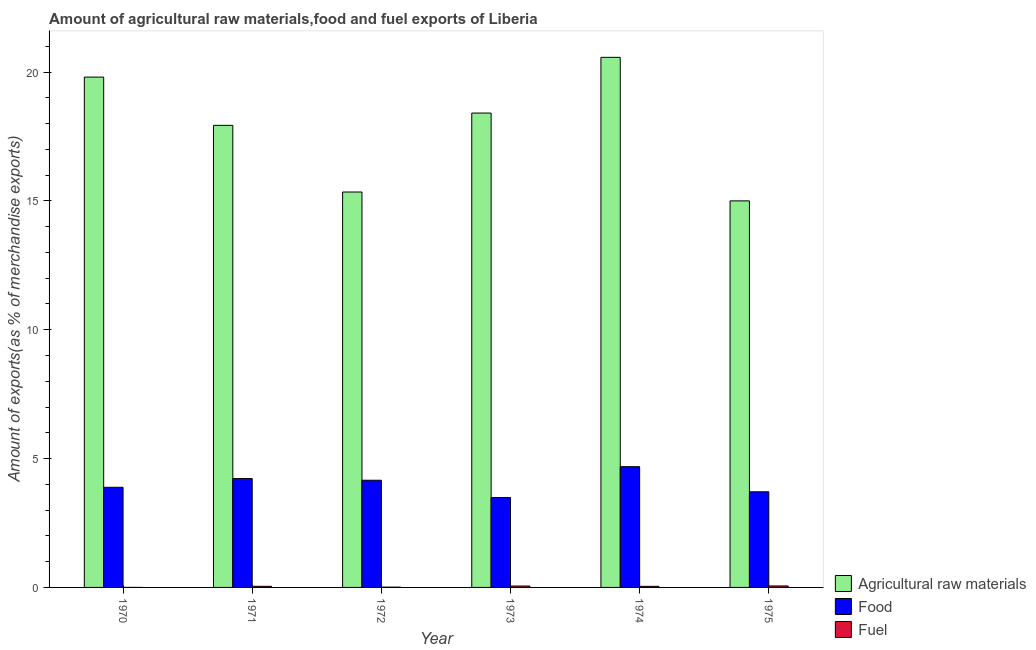How many different coloured bars are there?
Keep it short and to the point. 3. Are the number of bars per tick equal to the number of legend labels?
Keep it short and to the point. Yes. Are the number of bars on each tick of the X-axis equal?
Give a very brief answer. Yes. How many bars are there on the 6th tick from the left?
Your response must be concise. 3. What is the percentage of food exports in 1970?
Your answer should be compact. 3.88. Across all years, what is the maximum percentage of raw materials exports?
Your response must be concise. 20.57. Across all years, what is the minimum percentage of food exports?
Your response must be concise. 3.49. In which year was the percentage of raw materials exports maximum?
Offer a very short reply. 1974. In which year was the percentage of food exports minimum?
Make the answer very short. 1973. What is the total percentage of fuel exports in the graph?
Offer a very short reply. 0.21. What is the difference between the percentage of fuel exports in 1970 and that in 1974?
Offer a terse response. -0.04. What is the difference between the percentage of food exports in 1975 and the percentage of raw materials exports in 1970?
Give a very brief answer. -0.17. What is the average percentage of raw materials exports per year?
Give a very brief answer. 17.84. In the year 1970, what is the difference between the percentage of food exports and percentage of raw materials exports?
Provide a short and direct response. 0. What is the ratio of the percentage of fuel exports in 1973 to that in 1975?
Offer a very short reply. 0.95. Is the percentage of raw materials exports in 1970 less than that in 1973?
Your response must be concise. No. Is the difference between the percentage of raw materials exports in 1971 and 1974 greater than the difference between the percentage of fuel exports in 1971 and 1974?
Give a very brief answer. No. What is the difference between the highest and the second highest percentage of fuel exports?
Provide a short and direct response. 0. What is the difference between the highest and the lowest percentage of fuel exports?
Your answer should be compact. 0.06. In how many years, is the percentage of raw materials exports greater than the average percentage of raw materials exports taken over all years?
Your response must be concise. 4. What does the 1st bar from the left in 1974 represents?
Ensure brevity in your answer.  Agricultural raw materials. What does the 3rd bar from the right in 1974 represents?
Ensure brevity in your answer.  Agricultural raw materials. Is it the case that in every year, the sum of the percentage of raw materials exports and percentage of food exports is greater than the percentage of fuel exports?
Provide a succinct answer. Yes. Are the values on the major ticks of Y-axis written in scientific E-notation?
Keep it short and to the point. No. Does the graph contain any zero values?
Make the answer very short. No. Does the graph contain grids?
Make the answer very short. No. How are the legend labels stacked?
Offer a very short reply. Vertical. What is the title of the graph?
Give a very brief answer. Amount of agricultural raw materials,food and fuel exports of Liberia. Does "Natural gas sources" appear as one of the legend labels in the graph?
Give a very brief answer. No. What is the label or title of the Y-axis?
Your answer should be compact. Amount of exports(as % of merchandise exports). What is the Amount of exports(as % of merchandise exports) of Agricultural raw materials in 1970?
Provide a succinct answer. 19.8. What is the Amount of exports(as % of merchandise exports) in Food in 1970?
Provide a succinct answer. 3.88. What is the Amount of exports(as % of merchandise exports) of Fuel in 1970?
Give a very brief answer. 0. What is the Amount of exports(as % of merchandise exports) in Agricultural raw materials in 1971?
Make the answer very short. 17.93. What is the Amount of exports(as % of merchandise exports) in Food in 1971?
Your response must be concise. 4.22. What is the Amount of exports(as % of merchandise exports) of Fuel in 1971?
Your answer should be compact. 0.04. What is the Amount of exports(as % of merchandise exports) in Agricultural raw materials in 1972?
Your response must be concise. 15.34. What is the Amount of exports(as % of merchandise exports) in Food in 1972?
Your answer should be very brief. 4.16. What is the Amount of exports(as % of merchandise exports) in Fuel in 1972?
Provide a short and direct response. 0.01. What is the Amount of exports(as % of merchandise exports) of Agricultural raw materials in 1973?
Provide a short and direct response. 18.41. What is the Amount of exports(as % of merchandise exports) in Food in 1973?
Provide a short and direct response. 3.49. What is the Amount of exports(as % of merchandise exports) in Fuel in 1973?
Your answer should be compact. 0.05. What is the Amount of exports(as % of merchandise exports) in Agricultural raw materials in 1974?
Provide a succinct answer. 20.57. What is the Amount of exports(as % of merchandise exports) of Food in 1974?
Offer a very short reply. 4.69. What is the Amount of exports(as % of merchandise exports) of Fuel in 1974?
Ensure brevity in your answer.  0.04. What is the Amount of exports(as % of merchandise exports) in Agricultural raw materials in 1975?
Make the answer very short. 15. What is the Amount of exports(as % of merchandise exports) in Food in 1975?
Provide a succinct answer. 3.71. What is the Amount of exports(as % of merchandise exports) of Fuel in 1975?
Provide a succinct answer. 0.06. Across all years, what is the maximum Amount of exports(as % of merchandise exports) in Agricultural raw materials?
Ensure brevity in your answer.  20.57. Across all years, what is the maximum Amount of exports(as % of merchandise exports) of Food?
Keep it short and to the point. 4.69. Across all years, what is the maximum Amount of exports(as % of merchandise exports) in Fuel?
Make the answer very short. 0.06. Across all years, what is the minimum Amount of exports(as % of merchandise exports) in Agricultural raw materials?
Provide a succinct answer. 15. Across all years, what is the minimum Amount of exports(as % of merchandise exports) in Food?
Your answer should be very brief. 3.49. Across all years, what is the minimum Amount of exports(as % of merchandise exports) in Fuel?
Provide a succinct answer. 0. What is the total Amount of exports(as % of merchandise exports) in Agricultural raw materials in the graph?
Make the answer very short. 107.05. What is the total Amount of exports(as % of merchandise exports) in Food in the graph?
Your answer should be compact. 24.15. What is the total Amount of exports(as % of merchandise exports) in Fuel in the graph?
Offer a terse response. 0.21. What is the difference between the Amount of exports(as % of merchandise exports) in Agricultural raw materials in 1970 and that in 1971?
Your answer should be compact. 1.87. What is the difference between the Amount of exports(as % of merchandise exports) of Food in 1970 and that in 1971?
Your answer should be compact. -0.34. What is the difference between the Amount of exports(as % of merchandise exports) of Fuel in 1970 and that in 1971?
Give a very brief answer. -0.04. What is the difference between the Amount of exports(as % of merchandise exports) in Agricultural raw materials in 1970 and that in 1972?
Your response must be concise. 4.46. What is the difference between the Amount of exports(as % of merchandise exports) of Food in 1970 and that in 1972?
Ensure brevity in your answer.  -0.27. What is the difference between the Amount of exports(as % of merchandise exports) of Fuel in 1970 and that in 1972?
Offer a terse response. -0.01. What is the difference between the Amount of exports(as % of merchandise exports) of Agricultural raw materials in 1970 and that in 1973?
Provide a short and direct response. 1.4. What is the difference between the Amount of exports(as % of merchandise exports) in Food in 1970 and that in 1973?
Your answer should be very brief. 0.4. What is the difference between the Amount of exports(as % of merchandise exports) in Fuel in 1970 and that in 1973?
Give a very brief answer. -0.05. What is the difference between the Amount of exports(as % of merchandise exports) in Agricultural raw materials in 1970 and that in 1974?
Ensure brevity in your answer.  -0.77. What is the difference between the Amount of exports(as % of merchandise exports) of Food in 1970 and that in 1974?
Offer a very short reply. -0.8. What is the difference between the Amount of exports(as % of merchandise exports) in Fuel in 1970 and that in 1974?
Give a very brief answer. -0.04. What is the difference between the Amount of exports(as % of merchandise exports) of Agricultural raw materials in 1970 and that in 1975?
Your answer should be compact. 4.8. What is the difference between the Amount of exports(as % of merchandise exports) of Food in 1970 and that in 1975?
Your answer should be very brief. 0.17. What is the difference between the Amount of exports(as % of merchandise exports) in Fuel in 1970 and that in 1975?
Ensure brevity in your answer.  -0.06. What is the difference between the Amount of exports(as % of merchandise exports) of Agricultural raw materials in 1971 and that in 1972?
Give a very brief answer. 2.59. What is the difference between the Amount of exports(as % of merchandise exports) of Food in 1971 and that in 1972?
Provide a short and direct response. 0.07. What is the difference between the Amount of exports(as % of merchandise exports) in Fuel in 1971 and that in 1972?
Provide a short and direct response. 0.03. What is the difference between the Amount of exports(as % of merchandise exports) of Agricultural raw materials in 1971 and that in 1973?
Your answer should be very brief. -0.48. What is the difference between the Amount of exports(as % of merchandise exports) in Food in 1971 and that in 1973?
Ensure brevity in your answer.  0.74. What is the difference between the Amount of exports(as % of merchandise exports) of Fuel in 1971 and that in 1973?
Make the answer very short. -0.01. What is the difference between the Amount of exports(as % of merchandise exports) of Agricultural raw materials in 1971 and that in 1974?
Ensure brevity in your answer.  -2.64. What is the difference between the Amount of exports(as % of merchandise exports) of Food in 1971 and that in 1974?
Your answer should be very brief. -0.46. What is the difference between the Amount of exports(as % of merchandise exports) of Fuel in 1971 and that in 1974?
Give a very brief answer. 0. What is the difference between the Amount of exports(as % of merchandise exports) in Agricultural raw materials in 1971 and that in 1975?
Provide a succinct answer. 2.93. What is the difference between the Amount of exports(as % of merchandise exports) of Food in 1971 and that in 1975?
Ensure brevity in your answer.  0.51. What is the difference between the Amount of exports(as % of merchandise exports) in Fuel in 1971 and that in 1975?
Offer a very short reply. -0.01. What is the difference between the Amount of exports(as % of merchandise exports) in Agricultural raw materials in 1972 and that in 1973?
Provide a short and direct response. -3.06. What is the difference between the Amount of exports(as % of merchandise exports) of Food in 1972 and that in 1973?
Your answer should be very brief. 0.67. What is the difference between the Amount of exports(as % of merchandise exports) of Fuel in 1972 and that in 1973?
Your answer should be very brief. -0.04. What is the difference between the Amount of exports(as % of merchandise exports) in Agricultural raw materials in 1972 and that in 1974?
Give a very brief answer. -5.23. What is the difference between the Amount of exports(as % of merchandise exports) in Food in 1972 and that in 1974?
Ensure brevity in your answer.  -0.53. What is the difference between the Amount of exports(as % of merchandise exports) of Fuel in 1972 and that in 1974?
Your answer should be compact. -0.03. What is the difference between the Amount of exports(as % of merchandise exports) of Agricultural raw materials in 1972 and that in 1975?
Make the answer very short. 0.34. What is the difference between the Amount of exports(as % of merchandise exports) of Food in 1972 and that in 1975?
Offer a very short reply. 0.45. What is the difference between the Amount of exports(as % of merchandise exports) of Fuel in 1972 and that in 1975?
Keep it short and to the point. -0.05. What is the difference between the Amount of exports(as % of merchandise exports) in Agricultural raw materials in 1973 and that in 1974?
Your answer should be compact. -2.16. What is the difference between the Amount of exports(as % of merchandise exports) in Food in 1973 and that in 1974?
Provide a short and direct response. -1.2. What is the difference between the Amount of exports(as % of merchandise exports) in Fuel in 1973 and that in 1974?
Keep it short and to the point. 0.01. What is the difference between the Amount of exports(as % of merchandise exports) of Agricultural raw materials in 1973 and that in 1975?
Your response must be concise. 3.41. What is the difference between the Amount of exports(as % of merchandise exports) of Food in 1973 and that in 1975?
Provide a succinct answer. -0.22. What is the difference between the Amount of exports(as % of merchandise exports) in Fuel in 1973 and that in 1975?
Offer a terse response. -0. What is the difference between the Amount of exports(as % of merchandise exports) of Agricultural raw materials in 1974 and that in 1975?
Give a very brief answer. 5.57. What is the difference between the Amount of exports(as % of merchandise exports) in Food in 1974 and that in 1975?
Ensure brevity in your answer.  0.97. What is the difference between the Amount of exports(as % of merchandise exports) in Fuel in 1974 and that in 1975?
Ensure brevity in your answer.  -0.01. What is the difference between the Amount of exports(as % of merchandise exports) in Agricultural raw materials in 1970 and the Amount of exports(as % of merchandise exports) in Food in 1971?
Provide a short and direct response. 15.58. What is the difference between the Amount of exports(as % of merchandise exports) in Agricultural raw materials in 1970 and the Amount of exports(as % of merchandise exports) in Fuel in 1971?
Give a very brief answer. 19.76. What is the difference between the Amount of exports(as % of merchandise exports) of Food in 1970 and the Amount of exports(as % of merchandise exports) of Fuel in 1971?
Your answer should be very brief. 3.84. What is the difference between the Amount of exports(as % of merchandise exports) in Agricultural raw materials in 1970 and the Amount of exports(as % of merchandise exports) in Food in 1972?
Give a very brief answer. 15.64. What is the difference between the Amount of exports(as % of merchandise exports) in Agricultural raw materials in 1970 and the Amount of exports(as % of merchandise exports) in Fuel in 1972?
Provide a short and direct response. 19.79. What is the difference between the Amount of exports(as % of merchandise exports) in Food in 1970 and the Amount of exports(as % of merchandise exports) in Fuel in 1972?
Keep it short and to the point. 3.87. What is the difference between the Amount of exports(as % of merchandise exports) of Agricultural raw materials in 1970 and the Amount of exports(as % of merchandise exports) of Food in 1973?
Give a very brief answer. 16.32. What is the difference between the Amount of exports(as % of merchandise exports) in Agricultural raw materials in 1970 and the Amount of exports(as % of merchandise exports) in Fuel in 1973?
Your response must be concise. 19.75. What is the difference between the Amount of exports(as % of merchandise exports) in Food in 1970 and the Amount of exports(as % of merchandise exports) in Fuel in 1973?
Provide a succinct answer. 3.83. What is the difference between the Amount of exports(as % of merchandise exports) in Agricultural raw materials in 1970 and the Amount of exports(as % of merchandise exports) in Food in 1974?
Ensure brevity in your answer.  15.12. What is the difference between the Amount of exports(as % of merchandise exports) in Agricultural raw materials in 1970 and the Amount of exports(as % of merchandise exports) in Fuel in 1974?
Provide a succinct answer. 19.76. What is the difference between the Amount of exports(as % of merchandise exports) of Food in 1970 and the Amount of exports(as % of merchandise exports) of Fuel in 1974?
Provide a succinct answer. 3.84. What is the difference between the Amount of exports(as % of merchandise exports) in Agricultural raw materials in 1970 and the Amount of exports(as % of merchandise exports) in Food in 1975?
Provide a short and direct response. 16.09. What is the difference between the Amount of exports(as % of merchandise exports) in Agricultural raw materials in 1970 and the Amount of exports(as % of merchandise exports) in Fuel in 1975?
Provide a succinct answer. 19.75. What is the difference between the Amount of exports(as % of merchandise exports) in Food in 1970 and the Amount of exports(as % of merchandise exports) in Fuel in 1975?
Offer a terse response. 3.83. What is the difference between the Amount of exports(as % of merchandise exports) of Agricultural raw materials in 1971 and the Amount of exports(as % of merchandise exports) of Food in 1972?
Offer a very short reply. 13.77. What is the difference between the Amount of exports(as % of merchandise exports) in Agricultural raw materials in 1971 and the Amount of exports(as % of merchandise exports) in Fuel in 1972?
Provide a short and direct response. 17.92. What is the difference between the Amount of exports(as % of merchandise exports) in Food in 1971 and the Amount of exports(as % of merchandise exports) in Fuel in 1972?
Provide a short and direct response. 4.21. What is the difference between the Amount of exports(as % of merchandise exports) of Agricultural raw materials in 1971 and the Amount of exports(as % of merchandise exports) of Food in 1973?
Give a very brief answer. 14.44. What is the difference between the Amount of exports(as % of merchandise exports) in Agricultural raw materials in 1971 and the Amount of exports(as % of merchandise exports) in Fuel in 1973?
Your response must be concise. 17.88. What is the difference between the Amount of exports(as % of merchandise exports) of Food in 1971 and the Amount of exports(as % of merchandise exports) of Fuel in 1973?
Offer a terse response. 4.17. What is the difference between the Amount of exports(as % of merchandise exports) of Agricultural raw materials in 1971 and the Amount of exports(as % of merchandise exports) of Food in 1974?
Offer a terse response. 13.24. What is the difference between the Amount of exports(as % of merchandise exports) in Agricultural raw materials in 1971 and the Amount of exports(as % of merchandise exports) in Fuel in 1974?
Make the answer very short. 17.89. What is the difference between the Amount of exports(as % of merchandise exports) of Food in 1971 and the Amount of exports(as % of merchandise exports) of Fuel in 1974?
Provide a succinct answer. 4.18. What is the difference between the Amount of exports(as % of merchandise exports) in Agricultural raw materials in 1971 and the Amount of exports(as % of merchandise exports) in Food in 1975?
Ensure brevity in your answer.  14.22. What is the difference between the Amount of exports(as % of merchandise exports) in Agricultural raw materials in 1971 and the Amount of exports(as % of merchandise exports) in Fuel in 1975?
Your answer should be compact. 17.87. What is the difference between the Amount of exports(as % of merchandise exports) in Food in 1971 and the Amount of exports(as % of merchandise exports) in Fuel in 1975?
Ensure brevity in your answer.  4.17. What is the difference between the Amount of exports(as % of merchandise exports) of Agricultural raw materials in 1972 and the Amount of exports(as % of merchandise exports) of Food in 1973?
Ensure brevity in your answer.  11.86. What is the difference between the Amount of exports(as % of merchandise exports) of Agricultural raw materials in 1972 and the Amount of exports(as % of merchandise exports) of Fuel in 1973?
Provide a short and direct response. 15.29. What is the difference between the Amount of exports(as % of merchandise exports) of Food in 1972 and the Amount of exports(as % of merchandise exports) of Fuel in 1973?
Keep it short and to the point. 4.11. What is the difference between the Amount of exports(as % of merchandise exports) of Agricultural raw materials in 1972 and the Amount of exports(as % of merchandise exports) of Food in 1974?
Make the answer very short. 10.66. What is the difference between the Amount of exports(as % of merchandise exports) in Agricultural raw materials in 1972 and the Amount of exports(as % of merchandise exports) in Fuel in 1974?
Keep it short and to the point. 15.3. What is the difference between the Amount of exports(as % of merchandise exports) in Food in 1972 and the Amount of exports(as % of merchandise exports) in Fuel in 1974?
Your answer should be very brief. 4.12. What is the difference between the Amount of exports(as % of merchandise exports) in Agricultural raw materials in 1972 and the Amount of exports(as % of merchandise exports) in Food in 1975?
Offer a very short reply. 11.63. What is the difference between the Amount of exports(as % of merchandise exports) of Agricultural raw materials in 1972 and the Amount of exports(as % of merchandise exports) of Fuel in 1975?
Your answer should be compact. 15.29. What is the difference between the Amount of exports(as % of merchandise exports) in Food in 1972 and the Amount of exports(as % of merchandise exports) in Fuel in 1975?
Ensure brevity in your answer.  4.1. What is the difference between the Amount of exports(as % of merchandise exports) of Agricultural raw materials in 1973 and the Amount of exports(as % of merchandise exports) of Food in 1974?
Offer a terse response. 13.72. What is the difference between the Amount of exports(as % of merchandise exports) in Agricultural raw materials in 1973 and the Amount of exports(as % of merchandise exports) in Fuel in 1974?
Offer a terse response. 18.37. What is the difference between the Amount of exports(as % of merchandise exports) in Food in 1973 and the Amount of exports(as % of merchandise exports) in Fuel in 1974?
Give a very brief answer. 3.44. What is the difference between the Amount of exports(as % of merchandise exports) in Agricultural raw materials in 1973 and the Amount of exports(as % of merchandise exports) in Food in 1975?
Your answer should be very brief. 14.7. What is the difference between the Amount of exports(as % of merchandise exports) of Agricultural raw materials in 1973 and the Amount of exports(as % of merchandise exports) of Fuel in 1975?
Offer a terse response. 18.35. What is the difference between the Amount of exports(as % of merchandise exports) in Food in 1973 and the Amount of exports(as % of merchandise exports) in Fuel in 1975?
Keep it short and to the point. 3.43. What is the difference between the Amount of exports(as % of merchandise exports) in Agricultural raw materials in 1974 and the Amount of exports(as % of merchandise exports) in Food in 1975?
Provide a succinct answer. 16.86. What is the difference between the Amount of exports(as % of merchandise exports) in Agricultural raw materials in 1974 and the Amount of exports(as % of merchandise exports) in Fuel in 1975?
Give a very brief answer. 20.51. What is the difference between the Amount of exports(as % of merchandise exports) in Food in 1974 and the Amount of exports(as % of merchandise exports) in Fuel in 1975?
Offer a very short reply. 4.63. What is the average Amount of exports(as % of merchandise exports) in Agricultural raw materials per year?
Provide a succinct answer. 17.84. What is the average Amount of exports(as % of merchandise exports) of Food per year?
Ensure brevity in your answer.  4.03. What is the average Amount of exports(as % of merchandise exports) in Fuel per year?
Offer a very short reply. 0.03. In the year 1970, what is the difference between the Amount of exports(as % of merchandise exports) of Agricultural raw materials and Amount of exports(as % of merchandise exports) of Food?
Make the answer very short. 15.92. In the year 1970, what is the difference between the Amount of exports(as % of merchandise exports) of Agricultural raw materials and Amount of exports(as % of merchandise exports) of Fuel?
Provide a succinct answer. 19.8. In the year 1970, what is the difference between the Amount of exports(as % of merchandise exports) of Food and Amount of exports(as % of merchandise exports) of Fuel?
Your answer should be compact. 3.88. In the year 1971, what is the difference between the Amount of exports(as % of merchandise exports) of Agricultural raw materials and Amount of exports(as % of merchandise exports) of Food?
Provide a short and direct response. 13.71. In the year 1971, what is the difference between the Amount of exports(as % of merchandise exports) in Agricultural raw materials and Amount of exports(as % of merchandise exports) in Fuel?
Provide a short and direct response. 17.89. In the year 1971, what is the difference between the Amount of exports(as % of merchandise exports) in Food and Amount of exports(as % of merchandise exports) in Fuel?
Make the answer very short. 4.18. In the year 1972, what is the difference between the Amount of exports(as % of merchandise exports) in Agricultural raw materials and Amount of exports(as % of merchandise exports) in Food?
Give a very brief answer. 11.18. In the year 1972, what is the difference between the Amount of exports(as % of merchandise exports) of Agricultural raw materials and Amount of exports(as % of merchandise exports) of Fuel?
Your answer should be very brief. 15.33. In the year 1972, what is the difference between the Amount of exports(as % of merchandise exports) in Food and Amount of exports(as % of merchandise exports) in Fuel?
Your answer should be compact. 4.15. In the year 1973, what is the difference between the Amount of exports(as % of merchandise exports) in Agricultural raw materials and Amount of exports(as % of merchandise exports) in Food?
Keep it short and to the point. 14.92. In the year 1973, what is the difference between the Amount of exports(as % of merchandise exports) in Agricultural raw materials and Amount of exports(as % of merchandise exports) in Fuel?
Give a very brief answer. 18.35. In the year 1973, what is the difference between the Amount of exports(as % of merchandise exports) of Food and Amount of exports(as % of merchandise exports) of Fuel?
Offer a terse response. 3.43. In the year 1974, what is the difference between the Amount of exports(as % of merchandise exports) in Agricultural raw materials and Amount of exports(as % of merchandise exports) in Food?
Offer a very short reply. 15.88. In the year 1974, what is the difference between the Amount of exports(as % of merchandise exports) in Agricultural raw materials and Amount of exports(as % of merchandise exports) in Fuel?
Offer a terse response. 20.53. In the year 1974, what is the difference between the Amount of exports(as % of merchandise exports) in Food and Amount of exports(as % of merchandise exports) in Fuel?
Ensure brevity in your answer.  4.64. In the year 1975, what is the difference between the Amount of exports(as % of merchandise exports) in Agricultural raw materials and Amount of exports(as % of merchandise exports) in Food?
Offer a very short reply. 11.29. In the year 1975, what is the difference between the Amount of exports(as % of merchandise exports) of Agricultural raw materials and Amount of exports(as % of merchandise exports) of Fuel?
Keep it short and to the point. 14.94. In the year 1975, what is the difference between the Amount of exports(as % of merchandise exports) in Food and Amount of exports(as % of merchandise exports) in Fuel?
Ensure brevity in your answer.  3.65. What is the ratio of the Amount of exports(as % of merchandise exports) of Agricultural raw materials in 1970 to that in 1971?
Provide a succinct answer. 1.1. What is the ratio of the Amount of exports(as % of merchandise exports) in Food in 1970 to that in 1971?
Give a very brief answer. 0.92. What is the ratio of the Amount of exports(as % of merchandise exports) in Fuel in 1970 to that in 1971?
Your answer should be very brief. 0.01. What is the ratio of the Amount of exports(as % of merchandise exports) of Agricultural raw materials in 1970 to that in 1972?
Offer a terse response. 1.29. What is the ratio of the Amount of exports(as % of merchandise exports) in Food in 1970 to that in 1972?
Your answer should be very brief. 0.93. What is the ratio of the Amount of exports(as % of merchandise exports) of Fuel in 1970 to that in 1972?
Your answer should be compact. 0.05. What is the ratio of the Amount of exports(as % of merchandise exports) in Agricultural raw materials in 1970 to that in 1973?
Keep it short and to the point. 1.08. What is the ratio of the Amount of exports(as % of merchandise exports) of Food in 1970 to that in 1973?
Ensure brevity in your answer.  1.11. What is the ratio of the Amount of exports(as % of merchandise exports) in Fuel in 1970 to that in 1973?
Offer a terse response. 0.01. What is the ratio of the Amount of exports(as % of merchandise exports) in Agricultural raw materials in 1970 to that in 1974?
Keep it short and to the point. 0.96. What is the ratio of the Amount of exports(as % of merchandise exports) of Food in 1970 to that in 1974?
Your answer should be compact. 0.83. What is the ratio of the Amount of exports(as % of merchandise exports) of Fuel in 1970 to that in 1974?
Offer a terse response. 0.01. What is the ratio of the Amount of exports(as % of merchandise exports) in Agricultural raw materials in 1970 to that in 1975?
Offer a terse response. 1.32. What is the ratio of the Amount of exports(as % of merchandise exports) of Food in 1970 to that in 1975?
Your response must be concise. 1.05. What is the ratio of the Amount of exports(as % of merchandise exports) in Fuel in 1970 to that in 1975?
Provide a succinct answer. 0.01. What is the ratio of the Amount of exports(as % of merchandise exports) in Agricultural raw materials in 1971 to that in 1972?
Make the answer very short. 1.17. What is the ratio of the Amount of exports(as % of merchandise exports) of Food in 1971 to that in 1972?
Make the answer very short. 1.02. What is the ratio of the Amount of exports(as % of merchandise exports) in Fuel in 1971 to that in 1972?
Offer a terse response. 4.07. What is the ratio of the Amount of exports(as % of merchandise exports) in Agricultural raw materials in 1971 to that in 1973?
Your answer should be compact. 0.97. What is the ratio of the Amount of exports(as % of merchandise exports) in Food in 1971 to that in 1973?
Make the answer very short. 1.21. What is the ratio of the Amount of exports(as % of merchandise exports) in Fuel in 1971 to that in 1973?
Give a very brief answer. 0.8. What is the ratio of the Amount of exports(as % of merchandise exports) of Agricultural raw materials in 1971 to that in 1974?
Provide a succinct answer. 0.87. What is the ratio of the Amount of exports(as % of merchandise exports) in Food in 1971 to that in 1974?
Provide a short and direct response. 0.9. What is the ratio of the Amount of exports(as % of merchandise exports) of Agricultural raw materials in 1971 to that in 1975?
Provide a short and direct response. 1.2. What is the ratio of the Amount of exports(as % of merchandise exports) of Food in 1971 to that in 1975?
Ensure brevity in your answer.  1.14. What is the ratio of the Amount of exports(as % of merchandise exports) in Fuel in 1971 to that in 1975?
Provide a succinct answer. 0.76. What is the ratio of the Amount of exports(as % of merchandise exports) of Agricultural raw materials in 1972 to that in 1973?
Provide a succinct answer. 0.83. What is the ratio of the Amount of exports(as % of merchandise exports) of Food in 1972 to that in 1973?
Your answer should be compact. 1.19. What is the ratio of the Amount of exports(as % of merchandise exports) in Fuel in 1972 to that in 1973?
Make the answer very short. 0.2. What is the ratio of the Amount of exports(as % of merchandise exports) of Agricultural raw materials in 1972 to that in 1974?
Ensure brevity in your answer.  0.75. What is the ratio of the Amount of exports(as % of merchandise exports) in Food in 1972 to that in 1974?
Your answer should be compact. 0.89. What is the ratio of the Amount of exports(as % of merchandise exports) of Fuel in 1972 to that in 1974?
Your answer should be very brief. 0.25. What is the ratio of the Amount of exports(as % of merchandise exports) in Agricultural raw materials in 1972 to that in 1975?
Make the answer very short. 1.02. What is the ratio of the Amount of exports(as % of merchandise exports) of Food in 1972 to that in 1975?
Provide a short and direct response. 1.12. What is the ratio of the Amount of exports(as % of merchandise exports) in Fuel in 1972 to that in 1975?
Offer a terse response. 0.19. What is the ratio of the Amount of exports(as % of merchandise exports) of Agricultural raw materials in 1973 to that in 1974?
Your answer should be compact. 0.89. What is the ratio of the Amount of exports(as % of merchandise exports) of Food in 1973 to that in 1974?
Give a very brief answer. 0.74. What is the ratio of the Amount of exports(as % of merchandise exports) in Fuel in 1973 to that in 1974?
Provide a short and direct response. 1.28. What is the ratio of the Amount of exports(as % of merchandise exports) of Agricultural raw materials in 1973 to that in 1975?
Give a very brief answer. 1.23. What is the ratio of the Amount of exports(as % of merchandise exports) in Food in 1973 to that in 1975?
Offer a terse response. 0.94. What is the ratio of the Amount of exports(as % of merchandise exports) of Fuel in 1973 to that in 1975?
Offer a terse response. 0.95. What is the ratio of the Amount of exports(as % of merchandise exports) of Agricultural raw materials in 1974 to that in 1975?
Provide a short and direct response. 1.37. What is the ratio of the Amount of exports(as % of merchandise exports) in Food in 1974 to that in 1975?
Offer a terse response. 1.26. What is the ratio of the Amount of exports(as % of merchandise exports) in Fuel in 1974 to that in 1975?
Your response must be concise. 0.74. What is the difference between the highest and the second highest Amount of exports(as % of merchandise exports) of Agricultural raw materials?
Your answer should be very brief. 0.77. What is the difference between the highest and the second highest Amount of exports(as % of merchandise exports) in Food?
Give a very brief answer. 0.46. What is the difference between the highest and the second highest Amount of exports(as % of merchandise exports) of Fuel?
Your response must be concise. 0. What is the difference between the highest and the lowest Amount of exports(as % of merchandise exports) in Agricultural raw materials?
Offer a very short reply. 5.57. What is the difference between the highest and the lowest Amount of exports(as % of merchandise exports) in Food?
Offer a very short reply. 1.2. What is the difference between the highest and the lowest Amount of exports(as % of merchandise exports) in Fuel?
Ensure brevity in your answer.  0.06. 